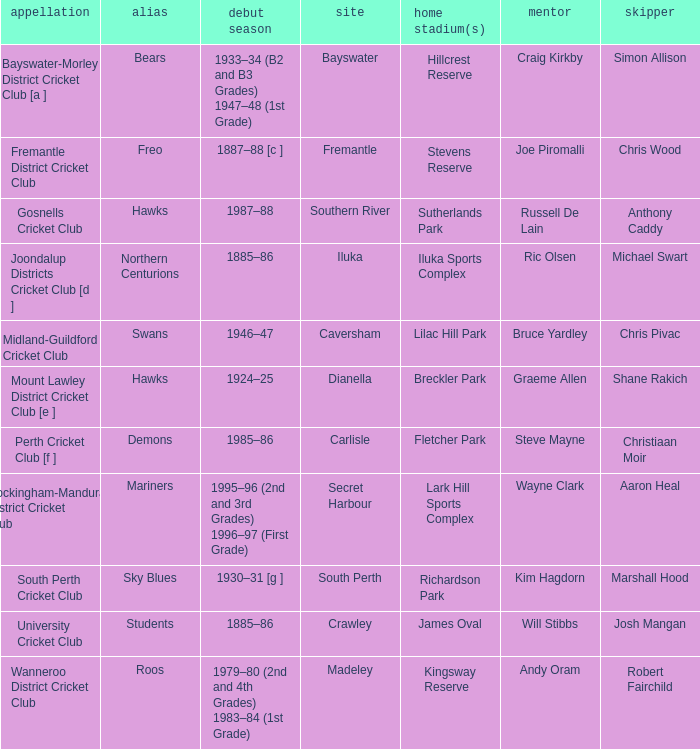With the nickname the swans, what is the home ground? Lilac Hill Park. Help me parse the entirety of this table. {'header': ['appellation', 'alias', 'debut season', 'site', 'home stadium(s)', 'mentor', 'skipper'], 'rows': [['Bayswater-Morley District Cricket Club [a ]', 'Bears', '1933–34 (B2 and B3 Grades) 1947–48 (1st Grade)', 'Bayswater', 'Hillcrest Reserve', 'Craig Kirkby', 'Simon Allison'], ['Fremantle District Cricket Club', 'Freo', '1887–88 [c ]', 'Fremantle', 'Stevens Reserve', 'Joe Piromalli', 'Chris Wood'], ['Gosnells Cricket Club', 'Hawks', '1987–88', 'Southern River', 'Sutherlands Park', 'Russell De Lain', 'Anthony Caddy'], ['Joondalup Districts Cricket Club [d ]', 'Northern Centurions', '1885–86', 'Iluka', 'Iluka Sports Complex', 'Ric Olsen', 'Michael Swart'], ['Midland-Guildford Cricket Club', 'Swans', '1946–47', 'Caversham', 'Lilac Hill Park', 'Bruce Yardley', 'Chris Pivac'], ['Mount Lawley District Cricket Club [e ]', 'Hawks', '1924–25', 'Dianella', 'Breckler Park', 'Graeme Allen', 'Shane Rakich'], ['Perth Cricket Club [f ]', 'Demons', '1985–86', 'Carlisle', 'Fletcher Park', 'Steve Mayne', 'Christiaan Moir'], ['Rockingham-Mandurah District Cricket Club', 'Mariners', '1995–96 (2nd and 3rd Grades) 1996–97 (First Grade)', 'Secret Harbour', 'Lark Hill Sports Complex', 'Wayne Clark', 'Aaron Heal'], ['South Perth Cricket Club', 'Sky Blues', '1930–31 [g ]', 'South Perth', 'Richardson Park', 'Kim Hagdorn', 'Marshall Hood'], ['University Cricket Club', 'Students', '1885–86', 'Crawley', 'James Oval', 'Will Stibbs', 'Josh Mangan'], ['Wanneroo District Cricket Club', 'Roos', '1979–80 (2nd and 4th Grades) 1983–84 (1st Grade)', 'Madeley', 'Kingsway Reserve', 'Andy Oram', 'Robert Fairchild']]} 